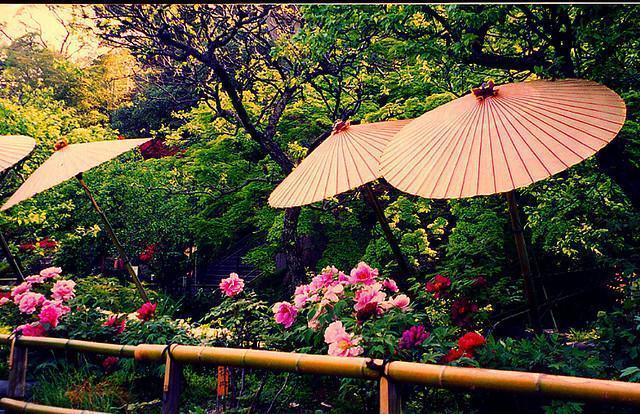How many umbrellas can you see?
Give a very brief answer. 3. 